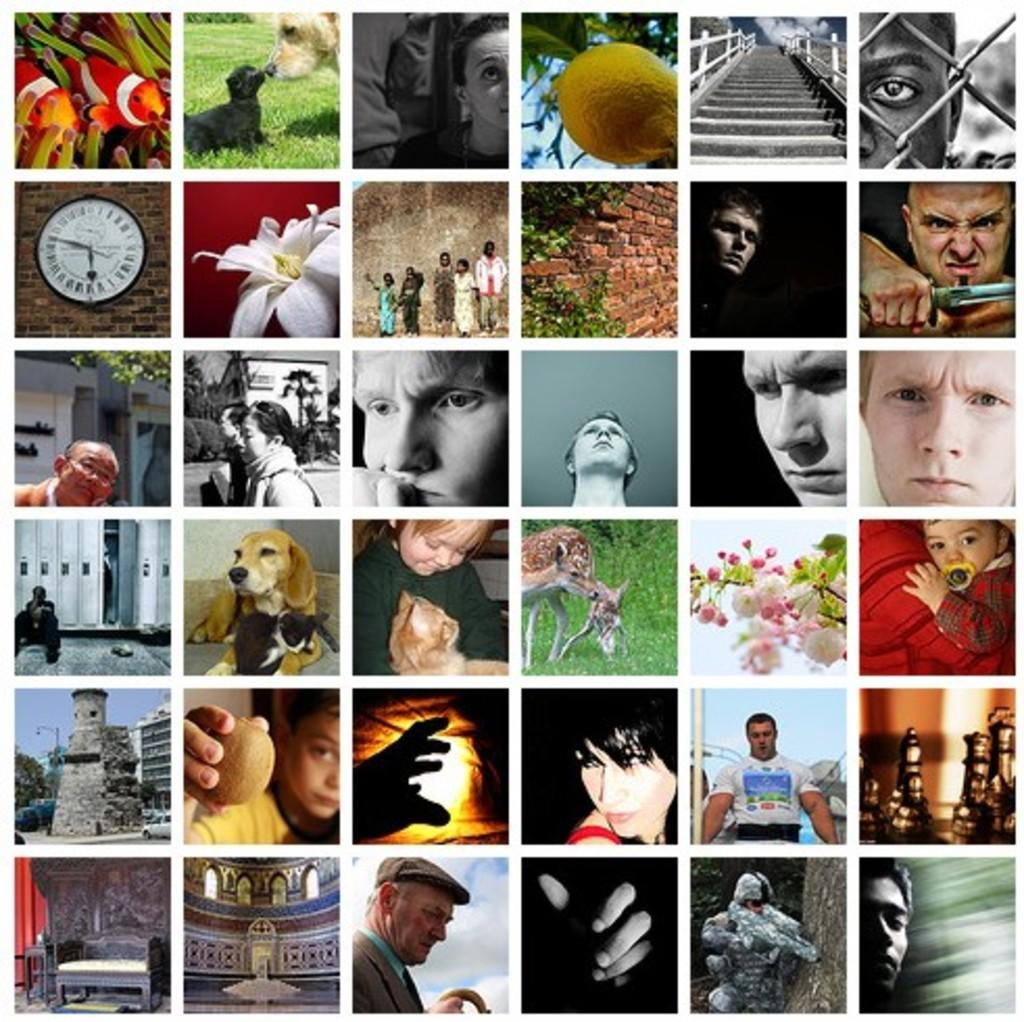What type of image is being described? The image is a collage of many different pictures. How are the pictures arranged in the collage? The arrangement of the pictures in the collage cannot be determined from the given fact. Can you describe any specific pictures within the collage? The given fact does not provide enough information to describe any specific pictures within the collage. How many balls are visible in the collage? There is no mention of any balls in the given fact, so it cannot be determined if any are present in the collage. 